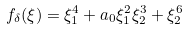Convert formula to latex. <formula><loc_0><loc_0><loc_500><loc_500>f _ { \delta } ( \xi ) = \xi _ { 1 } ^ { 4 } + a _ { 0 } \xi _ { 1 } ^ { 2 } \xi _ { 2 } ^ { 3 } + \xi _ { 2 } ^ { 6 }</formula> 